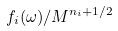Convert formula to latex. <formula><loc_0><loc_0><loc_500><loc_500>f _ { i } ( \omega ) / M ^ { n _ { i } + 1 / 2 }</formula> 